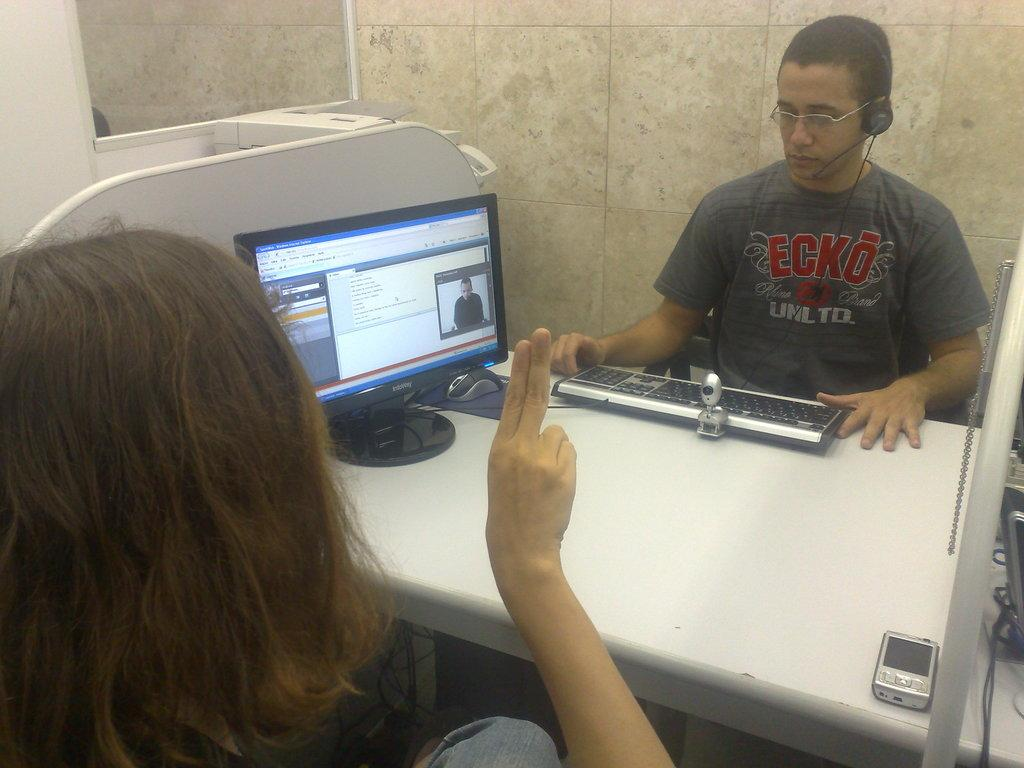<image>
Relay a brief, clear account of the picture shown. a boy sitting across from a girl that is wearing a shirt that says ecko on it 